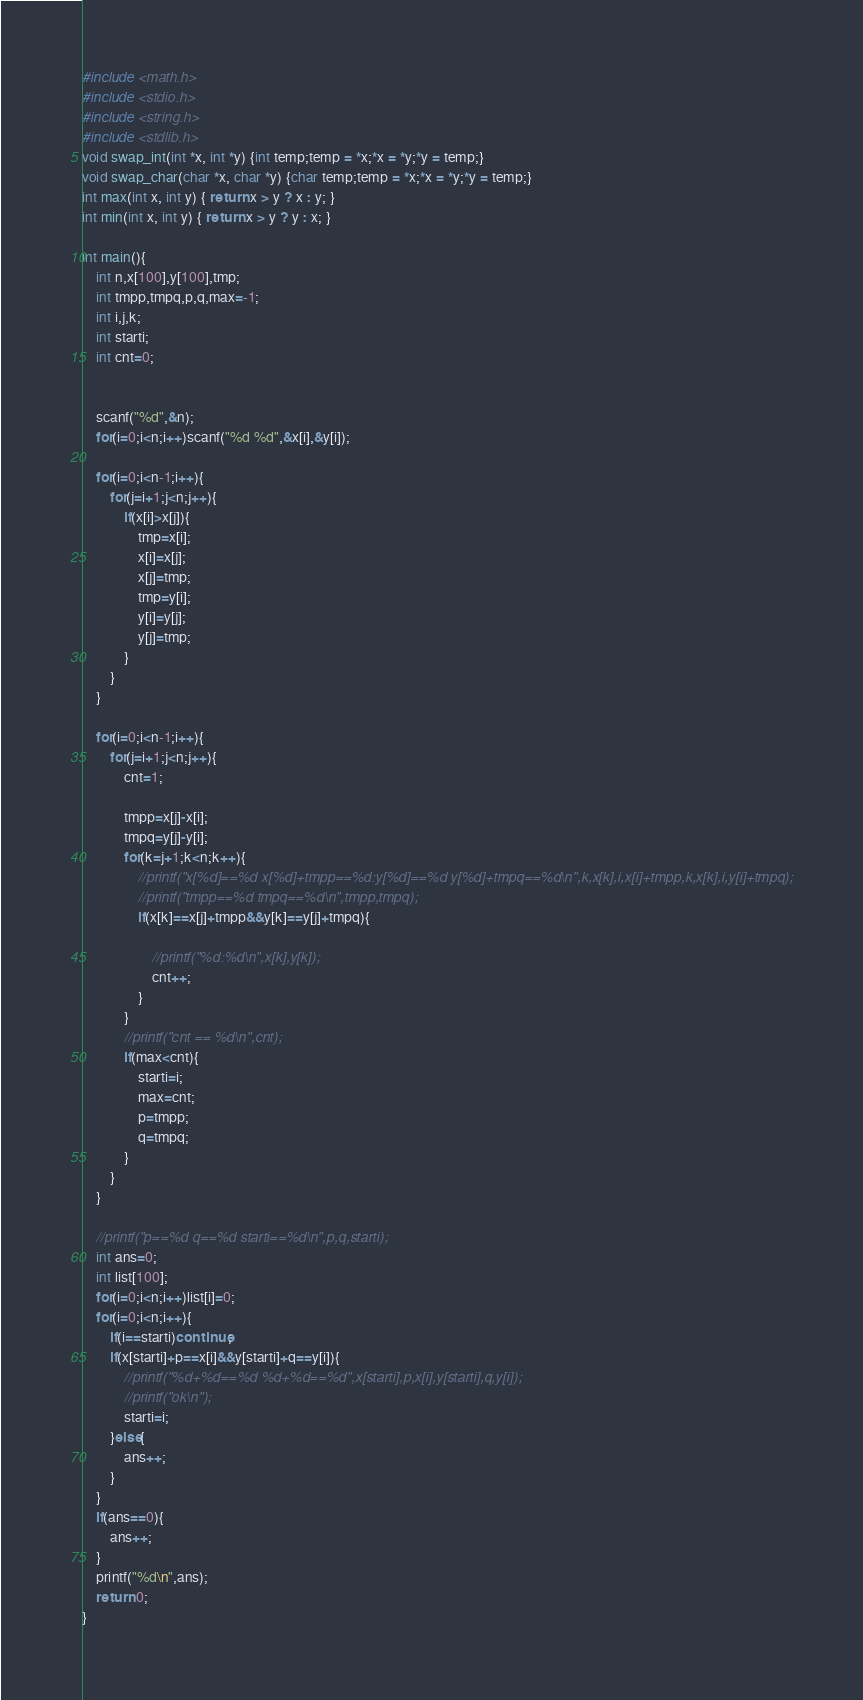<code> <loc_0><loc_0><loc_500><loc_500><_C_>#include <math.h>
#include <stdio.h>
#include <string.h>
#include <stdlib.h>
void swap_int(int *x, int *y) {int temp;temp = *x;*x = *y;*y = temp;}
void swap_char(char *x, char *y) {char temp;temp = *x;*x = *y;*y = temp;}
int max(int x, int y) { return x > y ? x : y; }
int min(int x, int y) { return x > y ? y : x; }

int main(){
    int n,x[100],y[100],tmp;
    int tmpp,tmpq,p,q,max=-1;
    int i,j,k;
    int starti;
    int cnt=0;


    scanf("%d",&n);
    for(i=0;i<n;i++)scanf("%d %d",&x[i],&y[i]);

    for(i=0;i<n-1;i++){
        for(j=i+1;j<n;j++){
            if(x[i]>x[j]){
                tmp=x[i];
                x[i]=x[j];
                x[j]=tmp;
                tmp=y[i];
                y[i]=y[j];
                y[j]=tmp;
            }
        }
    }

    for(i=0;i<n-1;i++){
        for(j=i+1;j<n;j++){
            cnt=1;

            tmpp=x[j]-x[i];
            tmpq=y[j]-y[i];
            for(k=j+1;k<n;k++){
                //printf("x[%d]==%d x[%d]+tmpp==%d:y[%d]==%d y[%d]+tmpq==%d\n",k,x[k],i,x[i]+tmpp,k,x[k],i,y[i]+tmpq);
                //printf("tmpp==%d tmpq==%d\n",tmpp,tmpq);
                if(x[k]==x[j]+tmpp&&y[k]==y[j]+tmpq){
                    
                    //printf("%d:%d\n",x[k],y[k]);
                    cnt++;
                }
            }
            //printf("cnt == %d\n",cnt);
            if(max<cnt){
                starti=i;
                max=cnt;
                p=tmpp;
                q=tmpq;
            }
        }
    }

    //printf("p==%d q==%d starti==%d\n",p,q,starti);
    int ans=0;
    int list[100];
    for(i=0;i<n;i++)list[i]=0;
    for(i=0;i<n;i++){
        if(i==starti)continue;
        if(x[starti]+p==x[i]&&y[starti]+q==y[i]){
            //printf("%d+%d==%d %d+%d==%d",x[starti],p,x[i],y[starti],q,y[i]);
            //printf("ok\n");
            starti=i;
        }else{
            ans++;
        }
    }
    if(ans==0){
        ans++;
    }
    printf("%d\n",ans);
    return 0;
}</code> 